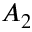<formula> <loc_0><loc_0><loc_500><loc_500>A _ { 2 }</formula> 